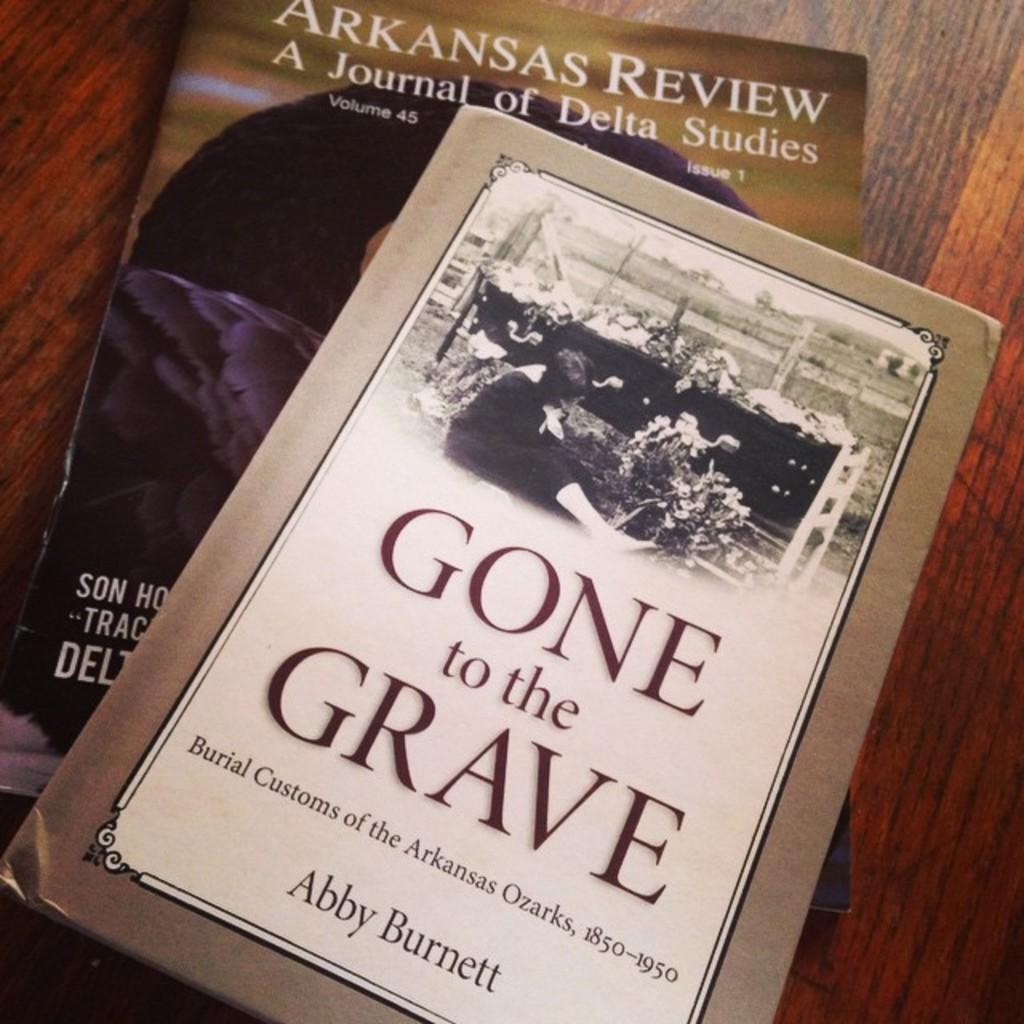<image>
Give a short and clear explanation of the subsequent image. 2 books set on the table with the cover called gone to the grave 